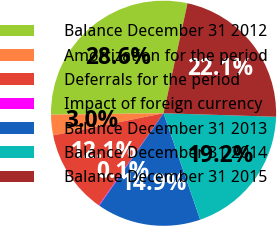Convert chart. <chart><loc_0><loc_0><loc_500><loc_500><pie_chart><fcel>Balance December 31 2012<fcel>Amortization for the period<fcel>Deferrals for the period<fcel>Impact of foreign currency<fcel>Balance December 31 2013<fcel>Balance December 31 2014<fcel>Balance December 31 2015<nl><fcel>28.62%<fcel>2.95%<fcel>12.08%<fcel>0.1%<fcel>14.94%<fcel>19.23%<fcel>22.08%<nl></chart> 